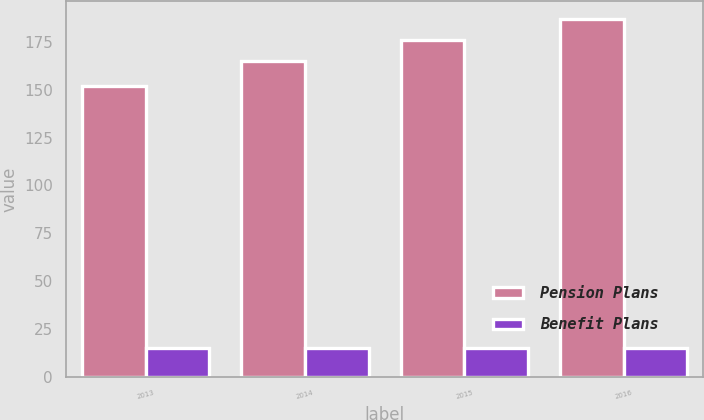<chart> <loc_0><loc_0><loc_500><loc_500><stacked_bar_chart><ecel><fcel>2013<fcel>2014<fcel>2015<fcel>2016<nl><fcel>Pension Plans<fcel>152<fcel>165<fcel>176<fcel>187<nl><fcel>Benefit Plans<fcel>15<fcel>15<fcel>15<fcel>15<nl></chart> 